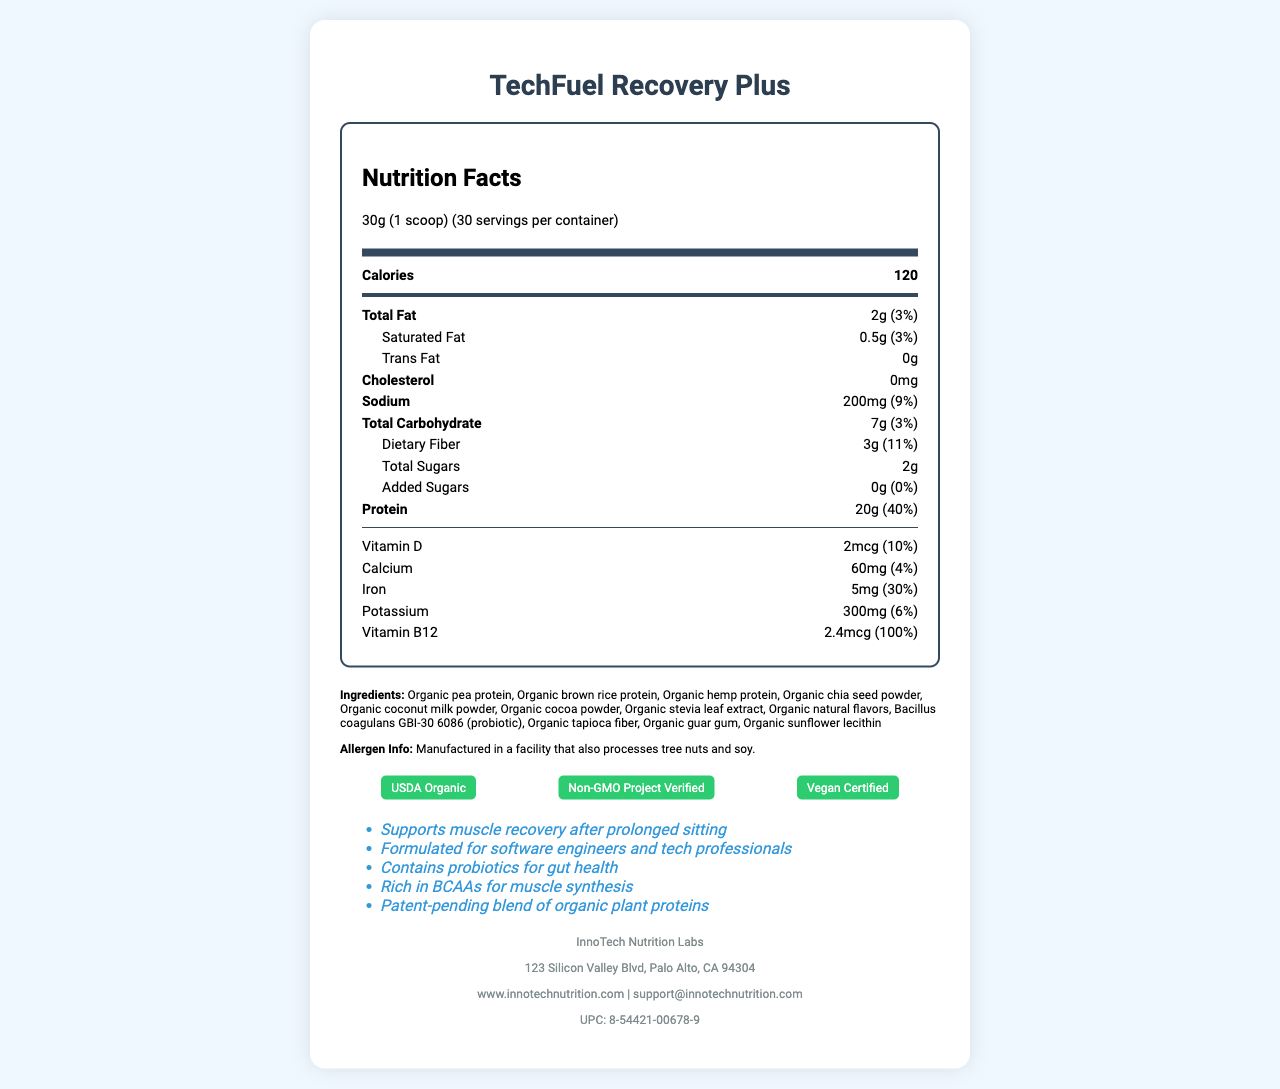what is the serving size? The serving size is clearly mentioned at the top part of the document under the Nutrition Facts section.
Answer: 30g (1 scoop) how many servings are there per container? The servings per container are listed right next to the serving size in the Nutrition Facts section.
Answer: 30 what is the main brand name of the product? The product name is displayed at the top of the document.
Answer: TechFuel Recovery Plus how many grams of protein are there per serving? The protein amount per serving is found in the protein row in the Nutrition Facts section.
Answer: 20g what certifications does the product have? These certifications are listed in the Certifications section at the bottom of the document.
Answer: USDA Organic, Non-GMO Project Verified, Vegan Certified what are the primary ingredients? The ingredients are listed in the Ingredients section of the document.
Answer: Organic pea protein, Organic brown rice protein, Organic hemp protein, Organic chia seed powder, Organic coconut milk powder, Organic cocoa powder, Organic stevia leaf extract, Organic natural flavors, Bacillus coagulans GBI-30 6086 (probiotic), Organic tapioca fiber, Organic guar gum, Organic sunflower lecithin what is the daily value percentage of Iron per serving? The daily value percentage of Iron is specified in the Iron row in the Nutrition Facts section.
Answer: 30% does the product contain any cholesterol? The cholesterol amount is listed as 0mg in the Nutrition Facts section.
Answer: No how should the product be stored after opening? The storage instructions specify to refrigerate after opening.
Answer: Refrigerate for best quality how many calories are in one serving? The calorie count per serving is listed at the very top of the Nutrition Facts.
Answer: 120 what vitamin content supports the label claim "Supports muscle recovery after prolonged sitting"? The document notes that the product is rich in Vitamin B12, which is important for energy metabolism, potentially supporting muscle recovery claims.
Answer: Vitamin B12 what is the address of the manufacturer? The manufacturer's address is provided in the Manufacturer Info section at the bottom of the document.
Answer: 123 Silicon Valley Blvd, Palo Alto, CA 94304 how many grams of dietary fiber are in one serving? The dietary fiber amount per serving is listed in the dietary fiber row in the Nutrition Facts section.
Answer: 3g does the product contain animal-derived ingredients? The product is Vegan Certified per the Certifications section.
Answer: No in which section is "Bacillus coagulans GBI-30 6086" listed? Bacillus coagulans GBI-30 6086 is listed among the ingredients.
Answer: Ingredients section what probiotic is included in this product? This probiotic is listed in the Ingredients section.
Answer: Bacillus coagulans GBI-30 6086 how much calcium is in one serving? The calcium content per serving is provided in the Calcium row of the Nutrition Facts section.
Answer: 60mg what is the daily value percentage of sodium per serving? The daily value percentage for sodium is listed as 9% in the Nutrition Facts section.
Answer: 9% is the product gluten-free? The document does not provide specific information about gluten content.
Answer: Not enough information which of the following statements is not listed in the claim statements? A. Supports muscle recovery after prolonged sitting B. Enhances mental focus C. Formulated for software engineers and tech professionals The claim statements listed do not mention enhancing mental focus.
Answer: B Based on the document, summarize the main purpose of TechFuel Recovery Plus. The product's name, various sections including certifications, ingredients, nutritional values, and claim statements all point to this summary.
Answer: TechFuel Recovery Plus is an organic, plant-based protein powder designed for tech professionals to support muscle recovery after extended periods of sitting, with additional benefits for gut health and muscle synthesis, certified organic, non-GMO, and vegan. 